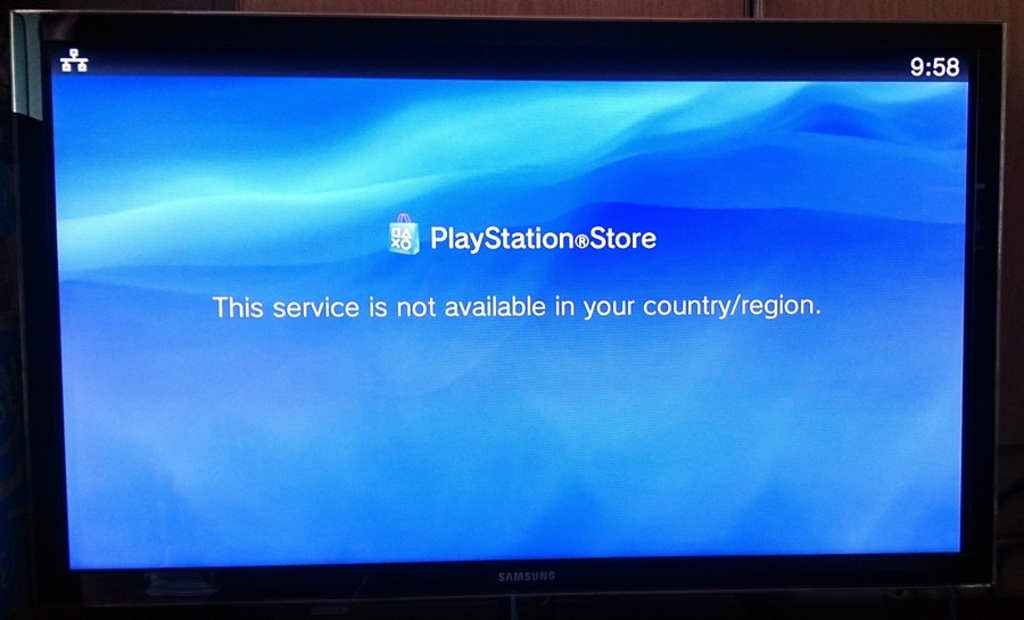What can a user do if they encounter such a message? When faced with a regional restriction message, a user has a few options. They can check if the PlayStation Store is legally accessible through other means in their region, such as a different internet provider who may not be subject to the same restrictions. Alternatively, they could use a Virtual Private Network (VPN) to access the store, although this may violate the service's terms of use. Contacting customer support for more information or waiting for the service to become available in their region are also viable steps. 